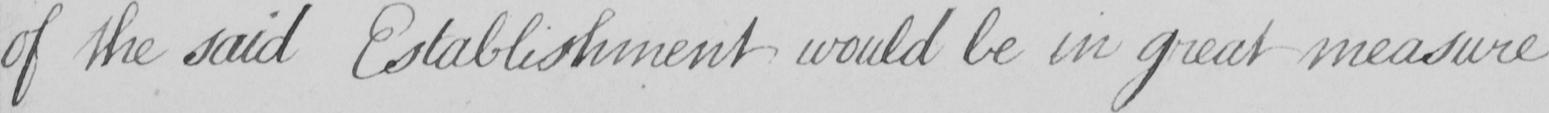Can you tell me what this handwritten text says? of the said Establishement would be in great measure 